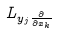Convert formula to latex. <formula><loc_0><loc_0><loc_500><loc_500>L _ { y _ { j } \frac { \partial } { \partial x _ { k } } }</formula> 